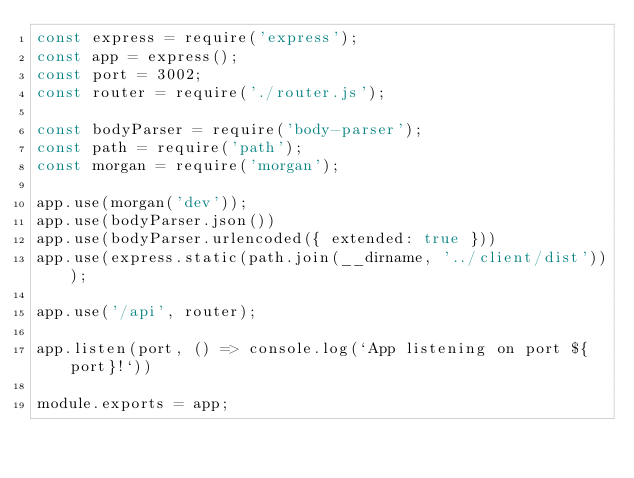<code> <loc_0><loc_0><loc_500><loc_500><_JavaScript_>const express = require('express');
const app = express();
const port = 3002;
const router = require('./router.js');

const bodyParser = require('body-parser');
const path = require('path');
const morgan = require('morgan');

app.use(morgan('dev'));
app.use(bodyParser.json())
app.use(bodyParser.urlencoded({ extended: true }))
app.use(express.static(path.join(__dirname, '../client/dist')));

app.use('/api', router);

app.listen(port, () => console.log(`App listening on port ${port}!`))

module.exports = app;
</code> 